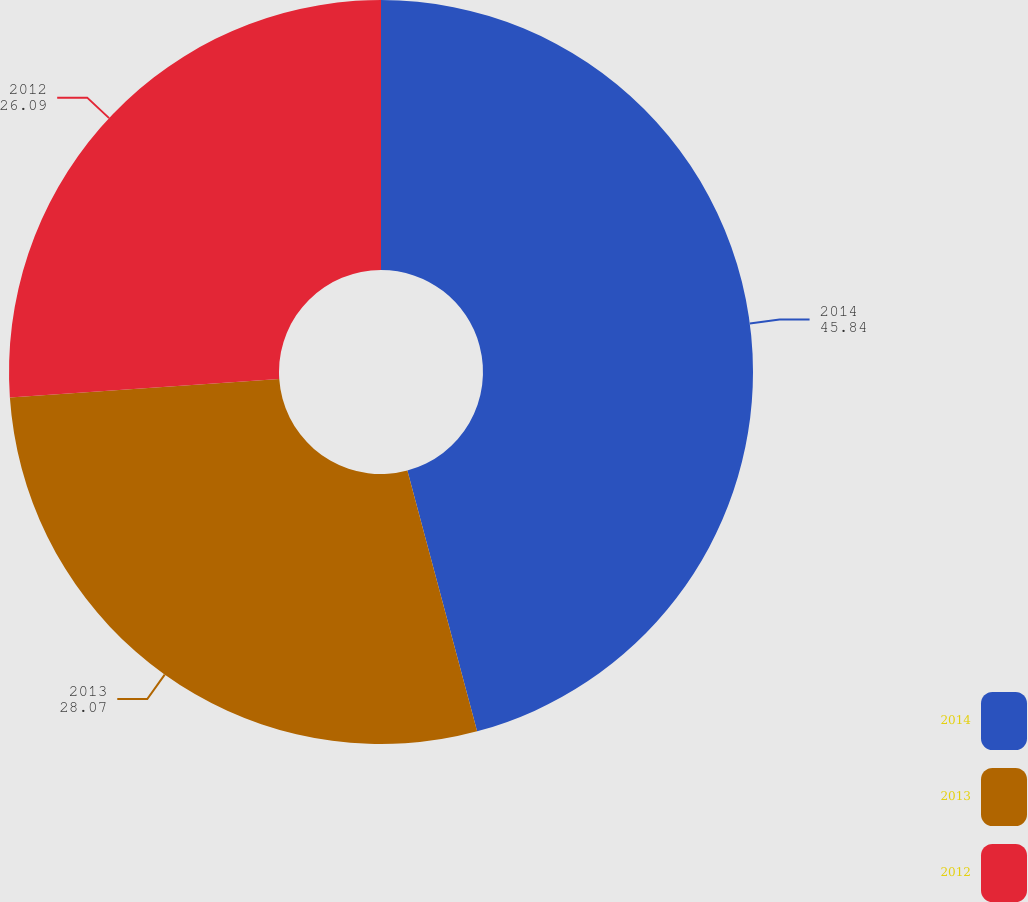Convert chart. <chart><loc_0><loc_0><loc_500><loc_500><pie_chart><fcel>2014<fcel>2013<fcel>2012<nl><fcel>45.84%<fcel>28.07%<fcel>26.09%<nl></chart> 